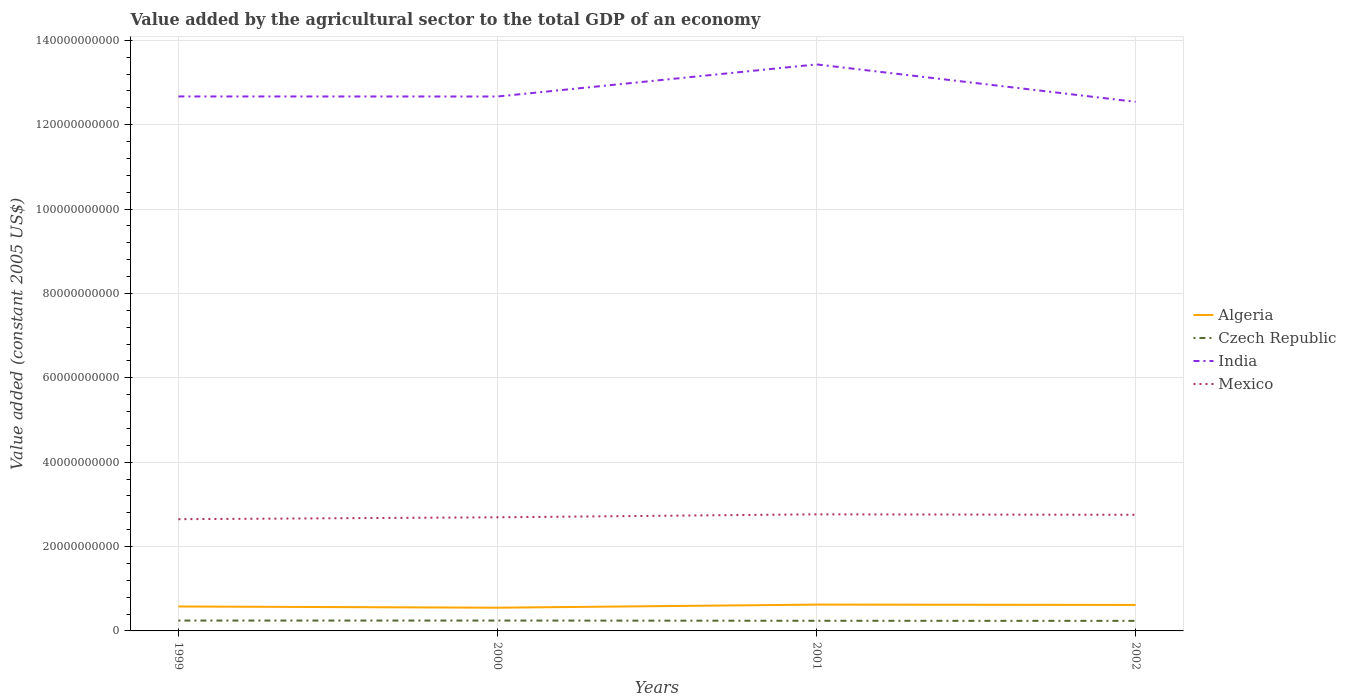Does the line corresponding to Czech Republic intersect with the line corresponding to Algeria?
Your answer should be very brief. No. Is the number of lines equal to the number of legend labels?
Your response must be concise. Yes. Across all years, what is the maximum value added by the agricultural sector in Algeria?
Offer a terse response. 5.50e+09. What is the total value added by the agricultural sector in Mexico in the graph?
Your answer should be compact. -4.48e+08. What is the difference between the highest and the second highest value added by the agricultural sector in Mexico?
Ensure brevity in your answer.  1.15e+09. What is the difference between the highest and the lowest value added by the agricultural sector in Czech Republic?
Provide a succinct answer. 2. What is the difference between two consecutive major ticks on the Y-axis?
Keep it short and to the point. 2.00e+1. Where does the legend appear in the graph?
Offer a terse response. Center right. What is the title of the graph?
Offer a very short reply. Value added by the agricultural sector to the total GDP of an economy. Does "Mongolia" appear as one of the legend labels in the graph?
Provide a short and direct response. No. What is the label or title of the X-axis?
Offer a very short reply. Years. What is the label or title of the Y-axis?
Give a very brief answer. Value added (constant 2005 US$). What is the Value added (constant 2005 US$) in Algeria in 1999?
Your answer should be very brief. 5.79e+09. What is the Value added (constant 2005 US$) in Czech Republic in 1999?
Your response must be concise. 2.46e+09. What is the Value added (constant 2005 US$) of India in 1999?
Ensure brevity in your answer.  1.27e+11. What is the Value added (constant 2005 US$) in Mexico in 1999?
Offer a terse response. 2.65e+1. What is the Value added (constant 2005 US$) in Algeria in 2000?
Your answer should be compact. 5.50e+09. What is the Value added (constant 2005 US$) in Czech Republic in 2000?
Keep it short and to the point. 2.46e+09. What is the Value added (constant 2005 US$) in India in 2000?
Provide a succinct answer. 1.27e+11. What is the Value added (constant 2005 US$) in Mexico in 2000?
Your answer should be compact. 2.69e+1. What is the Value added (constant 2005 US$) in Algeria in 2001?
Provide a short and direct response. 6.23e+09. What is the Value added (constant 2005 US$) in Czech Republic in 2001?
Your answer should be compact. 2.40e+09. What is the Value added (constant 2005 US$) of India in 2001?
Keep it short and to the point. 1.34e+11. What is the Value added (constant 2005 US$) in Mexico in 2001?
Provide a succinct answer. 2.76e+1. What is the Value added (constant 2005 US$) of Algeria in 2002?
Offer a terse response. 6.16e+09. What is the Value added (constant 2005 US$) in Czech Republic in 2002?
Give a very brief answer. 2.39e+09. What is the Value added (constant 2005 US$) of India in 2002?
Ensure brevity in your answer.  1.25e+11. What is the Value added (constant 2005 US$) of Mexico in 2002?
Make the answer very short. 2.75e+1. Across all years, what is the maximum Value added (constant 2005 US$) in Algeria?
Keep it short and to the point. 6.23e+09. Across all years, what is the maximum Value added (constant 2005 US$) of Czech Republic?
Offer a very short reply. 2.46e+09. Across all years, what is the maximum Value added (constant 2005 US$) in India?
Your answer should be very brief. 1.34e+11. Across all years, what is the maximum Value added (constant 2005 US$) in Mexico?
Your response must be concise. 2.76e+1. Across all years, what is the minimum Value added (constant 2005 US$) in Algeria?
Your response must be concise. 5.50e+09. Across all years, what is the minimum Value added (constant 2005 US$) in Czech Republic?
Offer a terse response. 2.39e+09. Across all years, what is the minimum Value added (constant 2005 US$) of India?
Offer a very short reply. 1.25e+11. Across all years, what is the minimum Value added (constant 2005 US$) of Mexico?
Give a very brief answer. 2.65e+1. What is the total Value added (constant 2005 US$) in Algeria in the graph?
Make the answer very short. 2.37e+1. What is the total Value added (constant 2005 US$) of Czech Republic in the graph?
Keep it short and to the point. 9.71e+09. What is the total Value added (constant 2005 US$) of India in the graph?
Give a very brief answer. 5.13e+11. What is the total Value added (constant 2005 US$) in Mexico in the graph?
Keep it short and to the point. 1.09e+11. What is the difference between the Value added (constant 2005 US$) of Algeria in 1999 and that in 2000?
Ensure brevity in your answer.  2.90e+08. What is the difference between the Value added (constant 2005 US$) of Czech Republic in 1999 and that in 2000?
Make the answer very short. -6.75e+05. What is the difference between the Value added (constant 2005 US$) in India in 1999 and that in 2000?
Keep it short and to the point. 9.65e+06. What is the difference between the Value added (constant 2005 US$) in Mexico in 1999 and that in 2000?
Ensure brevity in your answer.  -4.48e+08. What is the difference between the Value added (constant 2005 US$) in Algeria in 1999 and that in 2001?
Your response must be concise. -4.41e+08. What is the difference between the Value added (constant 2005 US$) of Czech Republic in 1999 and that in 2001?
Provide a succinct answer. 5.54e+07. What is the difference between the Value added (constant 2005 US$) of India in 1999 and that in 2001?
Offer a terse response. -7.60e+09. What is the difference between the Value added (constant 2005 US$) of Mexico in 1999 and that in 2001?
Make the answer very short. -1.15e+09. What is the difference between the Value added (constant 2005 US$) of Algeria in 1999 and that in 2002?
Keep it short and to the point. -3.66e+08. What is the difference between the Value added (constant 2005 US$) in Czech Republic in 1999 and that in 2002?
Provide a succinct answer. 7.14e+07. What is the difference between the Value added (constant 2005 US$) in India in 1999 and that in 2002?
Make the answer very short. 1.27e+09. What is the difference between the Value added (constant 2005 US$) of Mexico in 1999 and that in 2002?
Provide a short and direct response. -1.04e+09. What is the difference between the Value added (constant 2005 US$) in Algeria in 2000 and that in 2001?
Provide a short and direct response. -7.31e+08. What is the difference between the Value added (constant 2005 US$) of Czech Republic in 2000 and that in 2001?
Provide a succinct answer. 5.61e+07. What is the difference between the Value added (constant 2005 US$) of India in 2000 and that in 2001?
Provide a succinct answer. -7.61e+09. What is the difference between the Value added (constant 2005 US$) of Mexico in 2000 and that in 2001?
Ensure brevity in your answer.  -7.04e+08. What is the difference between the Value added (constant 2005 US$) in Algeria in 2000 and that in 2002?
Offer a terse response. -6.56e+08. What is the difference between the Value added (constant 2005 US$) of Czech Republic in 2000 and that in 2002?
Offer a terse response. 7.20e+07. What is the difference between the Value added (constant 2005 US$) in India in 2000 and that in 2002?
Offer a very short reply. 1.26e+09. What is the difference between the Value added (constant 2005 US$) of Mexico in 2000 and that in 2002?
Ensure brevity in your answer.  -5.94e+08. What is the difference between the Value added (constant 2005 US$) in Algeria in 2001 and that in 2002?
Make the answer very short. 7.48e+07. What is the difference between the Value added (constant 2005 US$) of Czech Republic in 2001 and that in 2002?
Ensure brevity in your answer.  1.59e+07. What is the difference between the Value added (constant 2005 US$) of India in 2001 and that in 2002?
Give a very brief answer. 8.87e+09. What is the difference between the Value added (constant 2005 US$) of Mexico in 2001 and that in 2002?
Offer a very short reply. 1.10e+08. What is the difference between the Value added (constant 2005 US$) in Algeria in 1999 and the Value added (constant 2005 US$) in Czech Republic in 2000?
Offer a terse response. 3.33e+09. What is the difference between the Value added (constant 2005 US$) of Algeria in 1999 and the Value added (constant 2005 US$) of India in 2000?
Keep it short and to the point. -1.21e+11. What is the difference between the Value added (constant 2005 US$) of Algeria in 1999 and the Value added (constant 2005 US$) of Mexico in 2000?
Your response must be concise. -2.11e+1. What is the difference between the Value added (constant 2005 US$) of Czech Republic in 1999 and the Value added (constant 2005 US$) of India in 2000?
Keep it short and to the point. -1.24e+11. What is the difference between the Value added (constant 2005 US$) in Czech Republic in 1999 and the Value added (constant 2005 US$) in Mexico in 2000?
Provide a succinct answer. -2.45e+1. What is the difference between the Value added (constant 2005 US$) of India in 1999 and the Value added (constant 2005 US$) of Mexico in 2000?
Keep it short and to the point. 9.97e+1. What is the difference between the Value added (constant 2005 US$) in Algeria in 1999 and the Value added (constant 2005 US$) in Czech Republic in 2001?
Provide a short and direct response. 3.39e+09. What is the difference between the Value added (constant 2005 US$) in Algeria in 1999 and the Value added (constant 2005 US$) in India in 2001?
Ensure brevity in your answer.  -1.28e+11. What is the difference between the Value added (constant 2005 US$) in Algeria in 1999 and the Value added (constant 2005 US$) in Mexico in 2001?
Provide a succinct answer. -2.18e+1. What is the difference between the Value added (constant 2005 US$) in Czech Republic in 1999 and the Value added (constant 2005 US$) in India in 2001?
Provide a succinct answer. -1.32e+11. What is the difference between the Value added (constant 2005 US$) of Czech Republic in 1999 and the Value added (constant 2005 US$) of Mexico in 2001?
Your answer should be compact. -2.52e+1. What is the difference between the Value added (constant 2005 US$) in India in 1999 and the Value added (constant 2005 US$) in Mexico in 2001?
Give a very brief answer. 9.90e+1. What is the difference between the Value added (constant 2005 US$) in Algeria in 1999 and the Value added (constant 2005 US$) in Czech Republic in 2002?
Your response must be concise. 3.41e+09. What is the difference between the Value added (constant 2005 US$) in Algeria in 1999 and the Value added (constant 2005 US$) in India in 2002?
Your answer should be very brief. -1.20e+11. What is the difference between the Value added (constant 2005 US$) in Algeria in 1999 and the Value added (constant 2005 US$) in Mexico in 2002?
Give a very brief answer. -2.17e+1. What is the difference between the Value added (constant 2005 US$) in Czech Republic in 1999 and the Value added (constant 2005 US$) in India in 2002?
Your answer should be compact. -1.23e+11. What is the difference between the Value added (constant 2005 US$) of Czech Republic in 1999 and the Value added (constant 2005 US$) of Mexico in 2002?
Your response must be concise. -2.51e+1. What is the difference between the Value added (constant 2005 US$) of India in 1999 and the Value added (constant 2005 US$) of Mexico in 2002?
Offer a terse response. 9.92e+1. What is the difference between the Value added (constant 2005 US$) of Algeria in 2000 and the Value added (constant 2005 US$) of Czech Republic in 2001?
Provide a short and direct response. 3.10e+09. What is the difference between the Value added (constant 2005 US$) in Algeria in 2000 and the Value added (constant 2005 US$) in India in 2001?
Keep it short and to the point. -1.29e+11. What is the difference between the Value added (constant 2005 US$) of Algeria in 2000 and the Value added (constant 2005 US$) of Mexico in 2001?
Your answer should be compact. -2.21e+1. What is the difference between the Value added (constant 2005 US$) of Czech Republic in 2000 and the Value added (constant 2005 US$) of India in 2001?
Your answer should be very brief. -1.32e+11. What is the difference between the Value added (constant 2005 US$) of Czech Republic in 2000 and the Value added (constant 2005 US$) of Mexico in 2001?
Make the answer very short. -2.52e+1. What is the difference between the Value added (constant 2005 US$) in India in 2000 and the Value added (constant 2005 US$) in Mexico in 2001?
Your answer should be very brief. 9.90e+1. What is the difference between the Value added (constant 2005 US$) in Algeria in 2000 and the Value added (constant 2005 US$) in Czech Republic in 2002?
Your response must be concise. 3.12e+09. What is the difference between the Value added (constant 2005 US$) in Algeria in 2000 and the Value added (constant 2005 US$) in India in 2002?
Provide a succinct answer. -1.20e+11. What is the difference between the Value added (constant 2005 US$) of Algeria in 2000 and the Value added (constant 2005 US$) of Mexico in 2002?
Provide a short and direct response. -2.20e+1. What is the difference between the Value added (constant 2005 US$) in Czech Republic in 2000 and the Value added (constant 2005 US$) in India in 2002?
Offer a terse response. -1.23e+11. What is the difference between the Value added (constant 2005 US$) of Czech Republic in 2000 and the Value added (constant 2005 US$) of Mexico in 2002?
Make the answer very short. -2.51e+1. What is the difference between the Value added (constant 2005 US$) of India in 2000 and the Value added (constant 2005 US$) of Mexico in 2002?
Your answer should be compact. 9.91e+1. What is the difference between the Value added (constant 2005 US$) in Algeria in 2001 and the Value added (constant 2005 US$) in Czech Republic in 2002?
Your response must be concise. 3.85e+09. What is the difference between the Value added (constant 2005 US$) of Algeria in 2001 and the Value added (constant 2005 US$) of India in 2002?
Give a very brief answer. -1.19e+11. What is the difference between the Value added (constant 2005 US$) of Algeria in 2001 and the Value added (constant 2005 US$) of Mexico in 2002?
Your response must be concise. -2.13e+1. What is the difference between the Value added (constant 2005 US$) in Czech Republic in 2001 and the Value added (constant 2005 US$) in India in 2002?
Offer a terse response. -1.23e+11. What is the difference between the Value added (constant 2005 US$) of Czech Republic in 2001 and the Value added (constant 2005 US$) of Mexico in 2002?
Offer a very short reply. -2.51e+1. What is the difference between the Value added (constant 2005 US$) in India in 2001 and the Value added (constant 2005 US$) in Mexico in 2002?
Keep it short and to the point. 1.07e+11. What is the average Value added (constant 2005 US$) in Algeria per year?
Provide a short and direct response. 5.92e+09. What is the average Value added (constant 2005 US$) of Czech Republic per year?
Your answer should be very brief. 2.43e+09. What is the average Value added (constant 2005 US$) in India per year?
Your response must be concise. 1.28e+11. What is the average Value added (constant 2005 US$) in Mexico per year?
Your answer should be very brief. 2.71e+1. In the year 1999, what is the difference between the Value added (constant 2005 US$) in Algeria and Value added (constant 2005 US$) in Czech Republic?
Ensure brevity in your answer.  3.33e+09. In the year 1999, what is the difference between the Value added (constant 2005 US$) of Algeria and Value added (constant 2005 US$) of India?
Offer a terse response. -1.21e+11. In the year 1999, what is the difference between the Value added (constant 2005 US$) in Algeria and Value added (constant 2005 US$) in Mexico?
Keep it short and to the point. -2.07e+1. In the year 1999, what is the difference between the Value added (constant 2005 US$) in Czech Republic and Value added (constant 2005 US$) in India?
Offer a very short reply. -1.24e+11. In the year 1999, what is the difference between the Value added (constant 2005 US$) of Czech Republic and Value added (constant 2005 US$) of Mexico?
Offer a very short reply. -2.40e+1. In the year 1999, what is the difference between the Value added (constant 2005 US$) of India and Value added (constant 2005 US$) of Mexico?
Make the answer very short. 1.00e+11. In the year 2000, what is the difference between the Value added (constant 2005 US$) in Algeria and Value added (constant 2005 US$) in Czech Republic?
Offer a very short reply. 3.04e+09. In the year 2000, what is the difference between the Value added (constant 2005 US$) in Algeria and Value added (constant 2005 US$) in India?
Keep it short and to the point. -1.21e+11. In the year 2000, what is the difference between the Value added (constant 2005 US$) of Algeria and Value added (constant 2005 US$) of Mexico?
Make the answer very short. -2.14e+1. In the year 2000, what is the difference between the Value added (constant 2005 US$) of Czech Republic and Value added (constant 2005 US$) of India?
Make the answer very short. -1.24e+11. In the year 2000, what is the difference between the Value added (constant 2005 US$) of Czech Republic and Value added (constant 2005 US$) of Mexico?
Your answer should be very brief. -2.45e+1. In the year 2000, what is the difference between the Value added (constant 2005 US$) of India and Value added (constant 2005 US$) of Mexico?
Provide a succinct answer. 9.97e+1. In the year 2001, what is the difference between the Value added (constant 2005 US$) in Algeria and Value added (constant 2005 US$) in Czech Republic?
Provide a succinct answer. 3.83e+09. In the year 2001, what is the difference between the Value added (constant 2005 US$) in Algeria and Value added (constant 2005 US$) in India?
Keep it short and to the point. -1.28e+11. In the year 2001, what is the difference between the Value added (constant 2005 US$) in Algeria and Value added (constant 2005 US$) in Mexico?
Provide a succinct answer. -2.14e+1. In the year 2001, what is the difference between the Value added (constant 2005 US$) in Czech Republic and Value added (constant 2005 US$) in India?
Ensure brevity in your answer.  -1.32e+11. In the year 2001, what is the difference between the Value added (constant 2005 US$) of Czech Republic and Value added (constant 2005 US$) of Mexico?
Keep it short and to the point. -2.52e+1. In the year 2001, what is the difference between the Value added (constant 2005 US$) of India and Value added (constant 2005 US$) of Mexico?
Provide a succinct answer. 1.07e+11. In the year 2002, what is the difference between the Value added (constant 2005 US$) of Algeria and Value added (constant 2005 US$) of Czech Republic?
Give a very brief answer. 3.77e+09. In the year 2002, what is the difference between the Value added (constant 2005 US$) of Algeria and Value added (constant 2005 US$) of India?
Give a very brief answer. -1.19e+11. In the year 2002, what is the difference between the Value added (constant 2005 US$) of Algeria and Value added (constant 2005 US$) of Mexico?
Make the answer very short. -2.14e+1. In the year 2002, what is the difference between the Value added (constant 2005 US$) in Czech Republic and Value added (constant 2005 US$) in India?
Provide a succinct answer. -1.23e+11. In the year 2002, what is the difference between the Value added (constant 2005 US$) in Czech Republic and Value added (constant 2005 US$) in Mexico?
Offer a very short reply. -2.51e+1. In the year 2002, what is the difference between the Value added (constant 2005 US$) of India and Value added (constant 2005 US$) of Mexico?
Keep it short and to the point. 9.79e+1. What is the ratio of the Value added (constant 2005 US$) of Algeria in 1999 to that in 2000?
Provide a succinct answer. 1.05. What is the ratio of the Value added (constant 2005 US$) of India in 1999 to that in 2000?
Provide a short and direct response. 1. What is the ratio of the Value added (constant 2005 US$) of Mexico in 1999 to that in 2000?
Offer a very short reply. 0.98. What is the ratio of the Value added (constant 2005 US$) in Algeria in 1999 to that in 2001?
Your answer should be compact. 0.93. What is the ratio of the Value added (constant 2005 US$) in Czech Republic in 1999 to that in 2001?
Make the answer very short. 1.02. What is the ratio of the Value added (constant 2005 US$) of India in 1999 to that in 2001?
Your response must be concise. 0.94. What is the ratio of the Value added (constant 2005 US$) of Algeria in 1999 to that in 2002?
Provide a short and direct response. 0.94. What is the ratio of the Value added (constant 2005 US$) in Czech Republic in 1999 to that in 2002?
Ensure brevity in your answer.  1.03. What is the ratio of the Value added (constant 2005 US$) in India in 1999 to that in 2002?
Your answer should be compact. 1.01. What is the ratio of the Value added (constant 2005 US$) of Mexico in 1999 to that in 2002?
Your answer should be very brief. 0.96. What is the ratio of the Value added (constant 2005 US$) in Algeria in 2000 to that in 2001?
Your answer should be compact. 0.88. What is the ratio of the Value added (constant 2005 US$) in Czech Republic in 2000 to that in 2001?
Provide a succinct answer. 1.02. What is the ratio of the Value added (constant 2005 US$) in India in 2000 to that in 2001?
Give a very brief answer. 0.94. What is the ratio of the Value added (constant 2005 US$) of Mexico in 2000 to that in 2001?
Offer a very short reply. 0.97. What is the ratio of the Value added (constant 2005 US$) in Algeria in 2000 to that in 2002?
Keep it short and to the point. 0.89. What is the ratio of the Value added (constant 2005 US$) of Czech Republic in 2000 to that in 2002?
Keep it short and to the point. 1.03. What is the ratio of the Value added (constant 2005 US$) of Mexico in 2000 to that in 2002?
Provide a succinct answer. 0.98. What is the ratio of the Value added (constant 2005 US$) of Algeria in 2001 to that in 2002?
Provide a succinct answer. 1.01. What is the ratio of the Value added (constant 2005 US$) of India in 2001 to that in 2002?
Offer a terse response. 1.07. What is the difference between the highest and the second highest Value added (constant 2005 US$) in Algeria?
Provide a succinct answer. 7.48e+07. What is the difference between the highest and the second highest Value added (constant 2005 US$) in Czech Republic?
Your response must be concise. 6.75e+05. What is the difference between the highest and the second highest Value added (constant 2005 US$) of India?
Offer a very short reply. 7.60e+09. What is the difference between the highest and the second highest Value added (constant 2005 US$) of Mexico?
Make the answer very short. 1.10e+08. What is the difference between the highest and the lowest Value added (constant 2005 US$) of Algeria?
Offer a terse response. 7.31e+08. What is the difference between the highest and the lowest Value added (constant 2005 US$) of Czech Republic?
Provide a short and direct response. 7.20e+07. What is the difference between the highest and the lowest Value added (constant 2005 US$) of India?
Ensure brevity in your answer.  8.87e+09. What is the difference between the highest and the lowest Value added (constant 2005 US$) in Mexico?
Provide a succinct answer. 1.15e+09. 